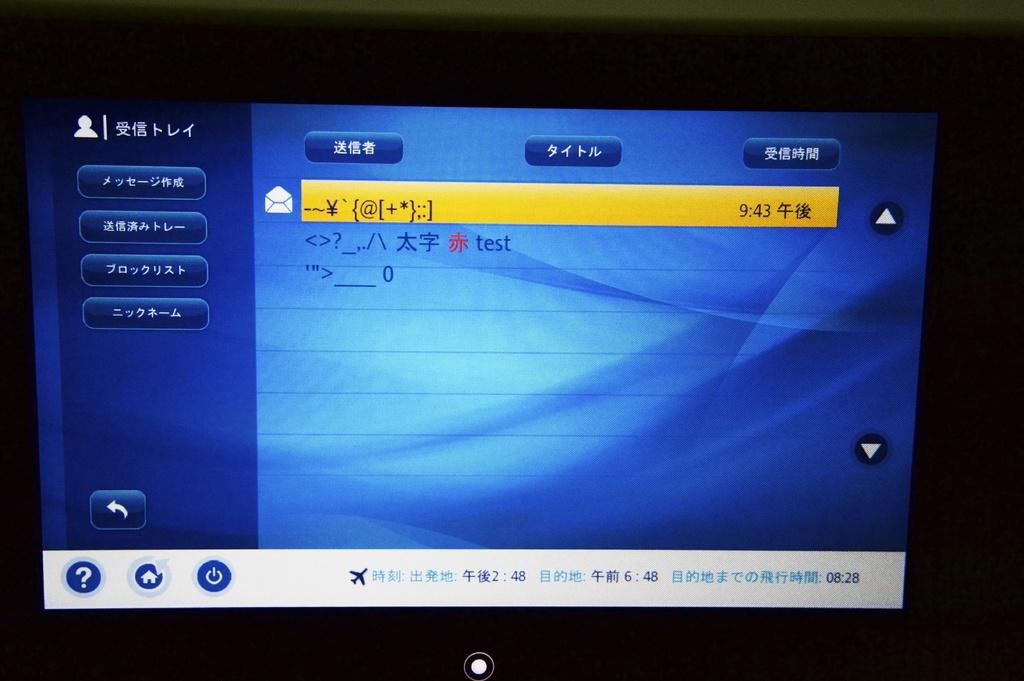<image>
Give a short and clear explanation of the subsequent image. A display screen shows three messages and one of them says test. 